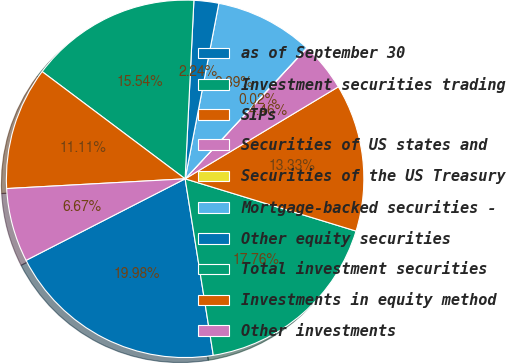Convert chart to OTSL. <chart><loc_0><loc_0><loc_500><loc_500><pie_chart><fcel>as of September 30<fcel>Investment securities trading<fcel>SIPs<fcel>Securities of US states and<fcel>Securities of the US Treasury<fcel>Mortgage-backed securities -<fcel>Other equity securities<fcel>Total investment securities<fcel>Investments in equity method<fcel>Other investments<nl><fcel>19.98%<fcel>17.76%<fcel>13.33%<fcel>4.46%<fcel>0.02%<fcel>8.89%<fcel>2.24%<fcel>15.54%<fcel>11.11%<fcel>6.67%<nl></chart> 